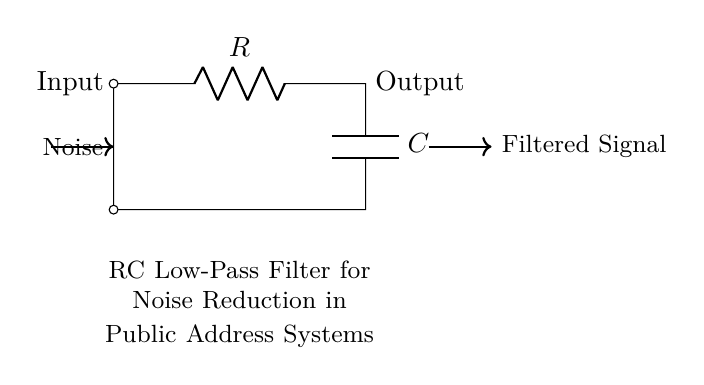What components are present in the circuit? The circuit contains a resistor and a capacitor, as indicated by the symbols labeled R and C.
Answer: resistor and capacitor What is the function of this circuit? The circuit is designed to filter noise, specifically acting as a low-pass filter to allow desired signals while reducing unwanted noise.
Answer: noise reduction What is the output of the circuit connected to? The output of the circuit is connected to the filtered signal, as shown by the arrow indicating the direction of the output flow.
Answer: filtered signal What type of filter is this circuit implementing? This circuit implements a low-pass filter, which is evident from the arrangement of the resistor and capacitor in series with the input and output connections.
Answer: low-pass filter How does the resistor affect the circuit's performance? The resistor in the circuit influences the cutoff frequency of the filter, which determines the frequency range of signals that can pass through while attenuating higher frequencies.
Answer: cutoff frequency What happens to high-frequency signals in this circuit? High-frequency signals are attenuated or reduced, because the low-pass filter characteristic allows only lower frequencies to pass through effectively while blocking higher frequencies.
Answer: attenuated 